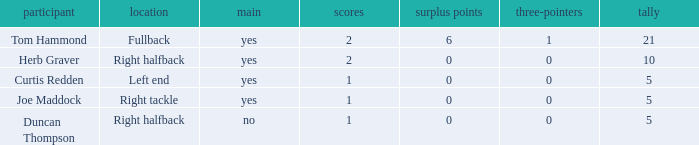Name the most extra points for right tackle 0.0. 